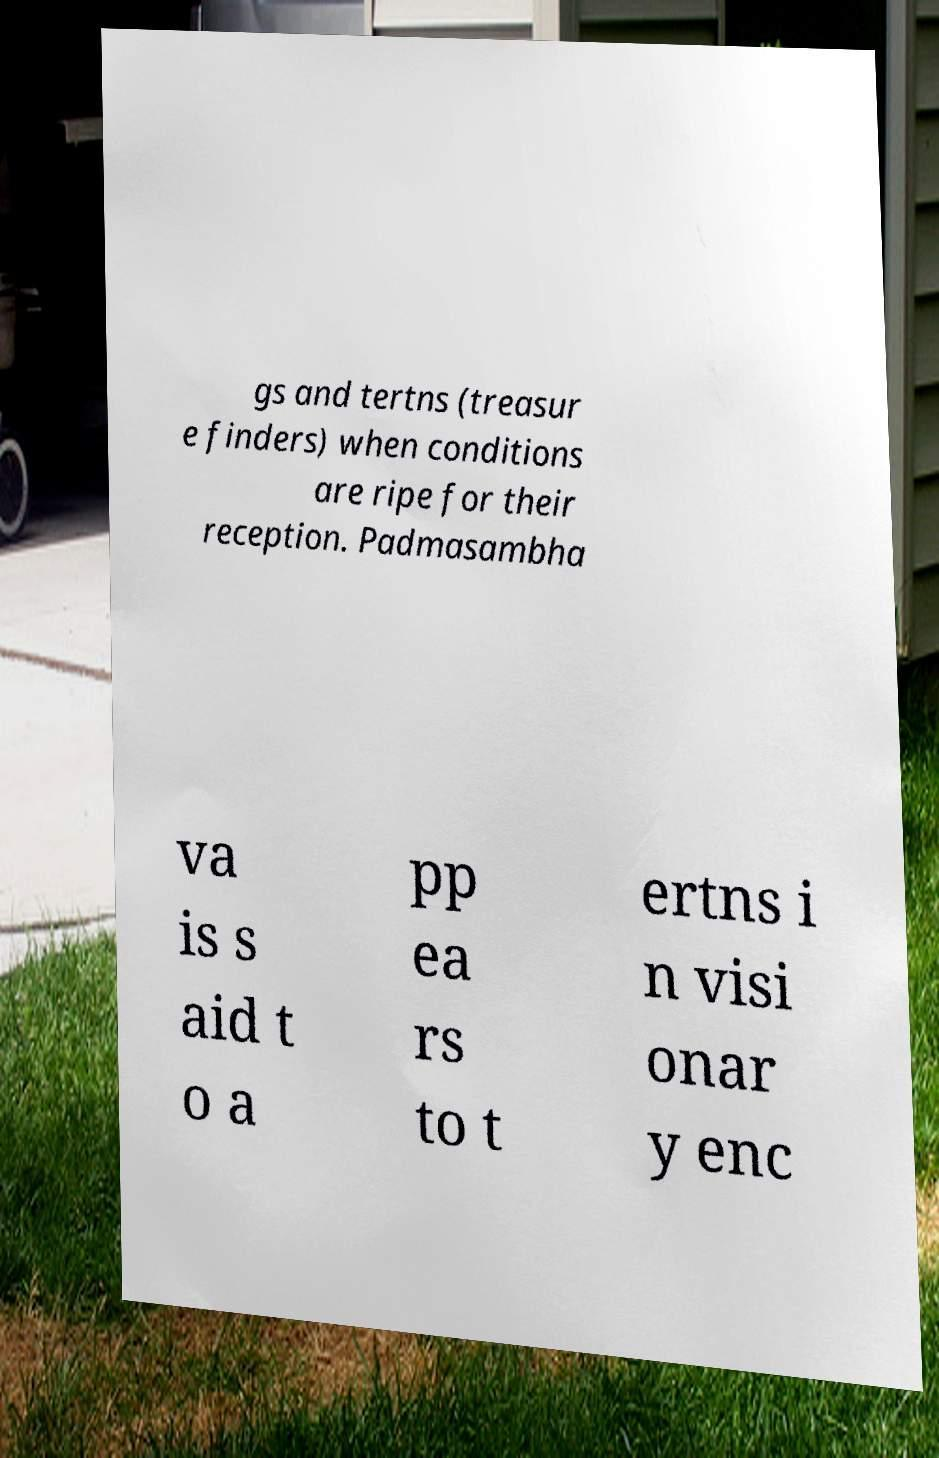What messages or text are displayed in this image? I need them in a readable, typed format. gs and tertns (treasur e finders) when conditions are ripe for their reception. Padmasambha va is s aid t o a pp ea rs to t ertns i n visi onar y enc 